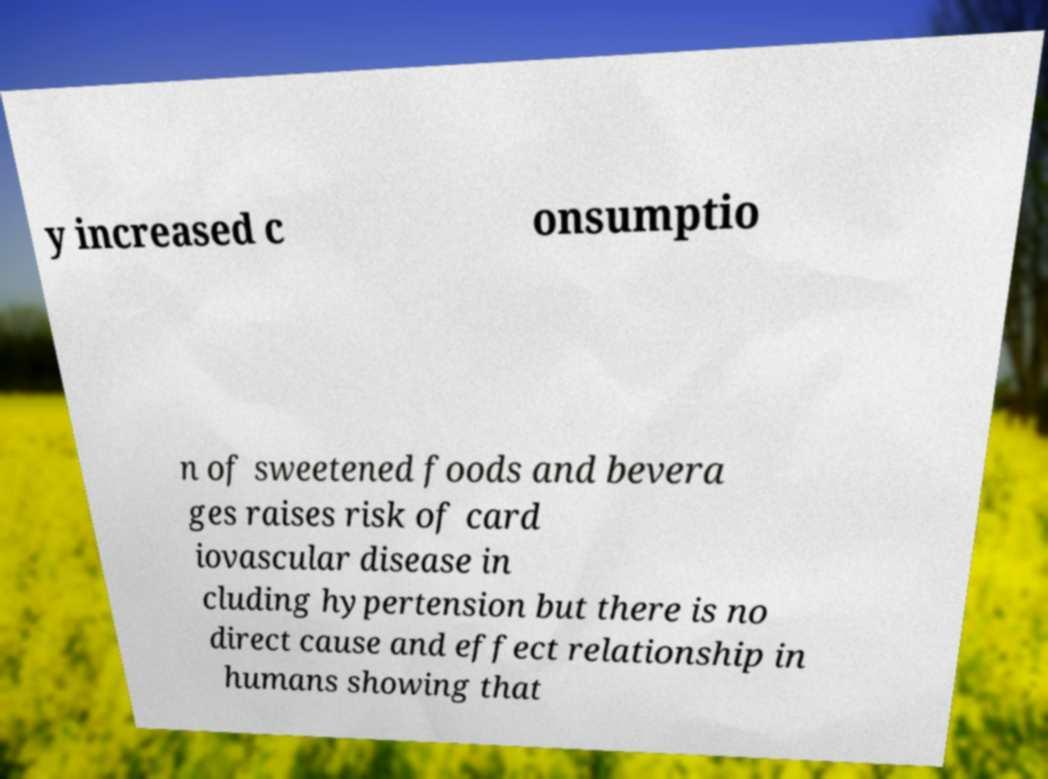Please read and relay the text visible in this image. What does it say? y increased c onsumptio n of sweetened foods and bevera ges raises risk of card iovascular disease in cluding hypertension but there is no direct cause and effect relationship in humans showing that 